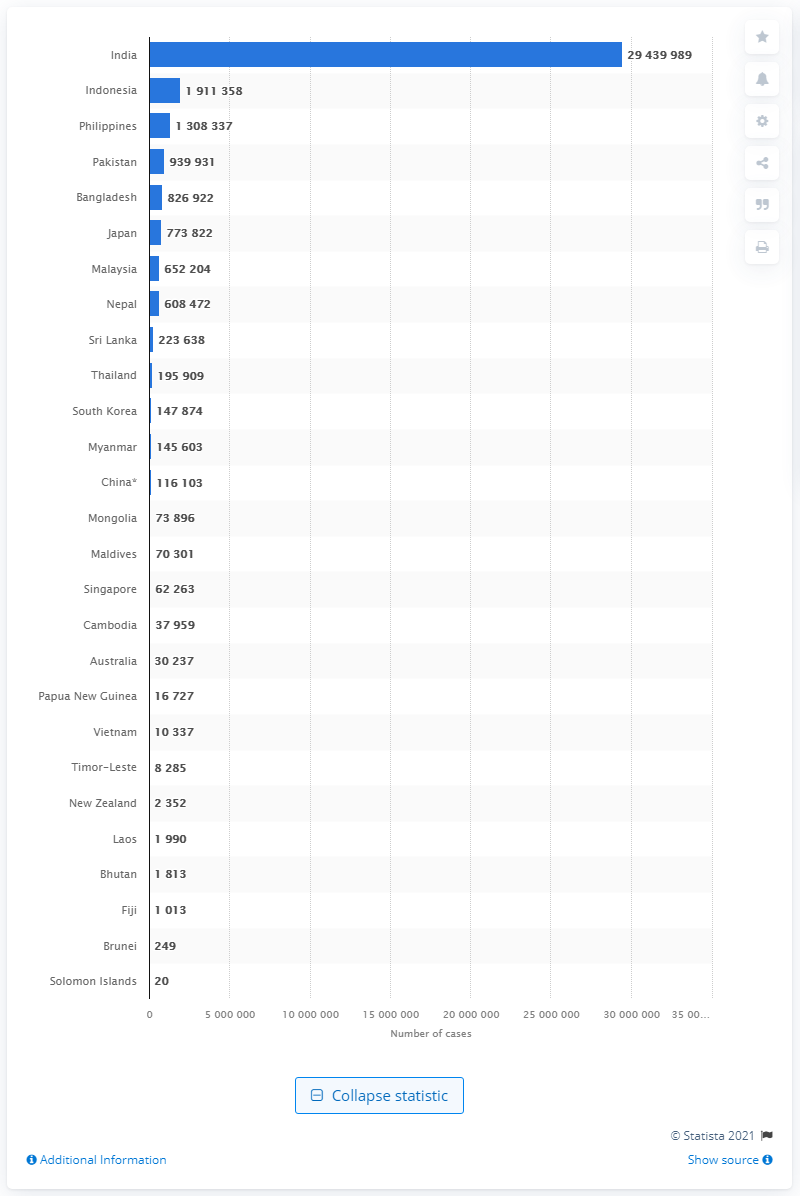Give some essential details in this illustration. India had a total of 294,399 cases of COVID-19 as of June 13, 2021. The prediction that the number of coronavirus cases would stabilize was made in South Korea. Indonesia had the second highest number of coronavirus cases in the Asia Pacific region. 